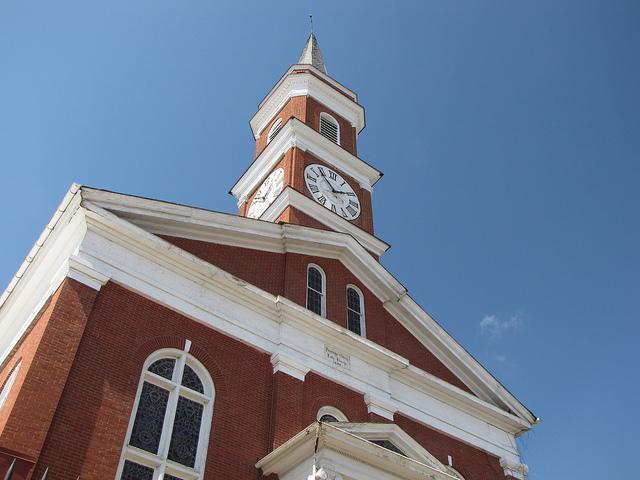How many people are holding an umbrella?
Give a very brief answer. 0. 